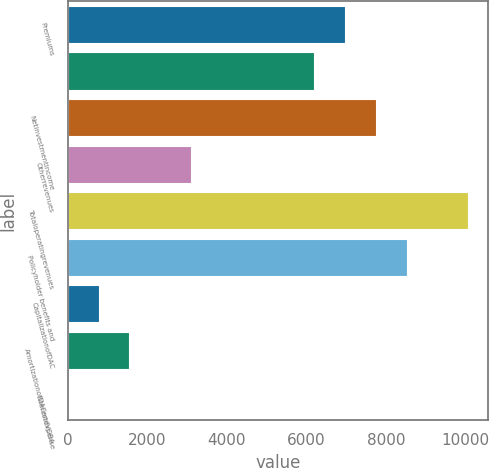Convert chart. <chart><loc_0><loc_0><loc_500><loc_500><bar_chart><fcel>Premiums<fcel>Unnamed: 1<fcel>Netinvestmentincome<fcel>Otherrevenues<fcel>Totaloperatingrevenues<fcel>Policyholder benefits and<fcel>CapitalizationofDAC<fcel>AmortizationofDACandVOBA<fcel>Interestexpense<nl><fcel>6968.1<fcel>6194.2<fcel>7742<fcel>3098.6<fcel>10063.7<fcel>8515.9<fcel>776.9<fcel>1550.8<fcel>3<nl></chart> 